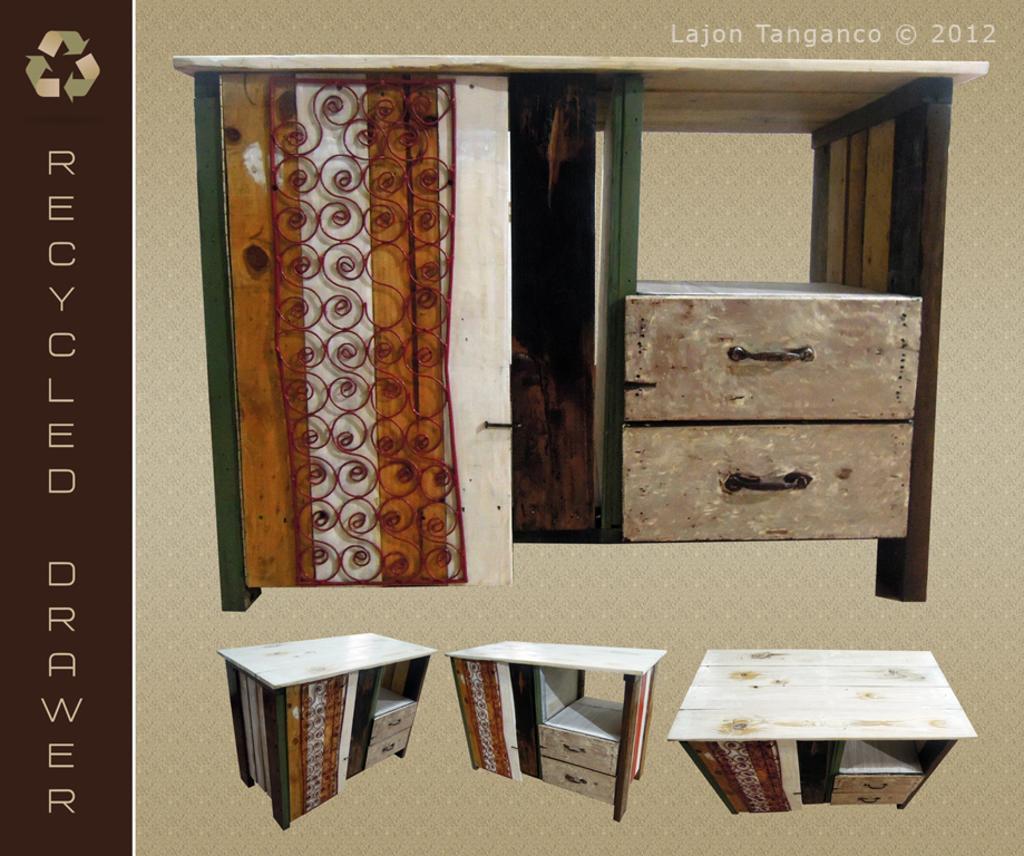How would you summarize this image in a sentence or two? there is a table which is white color. it has 2 drawers at the right. in the left recycled drawer is written. below the table there are three images if the table with different angles. 